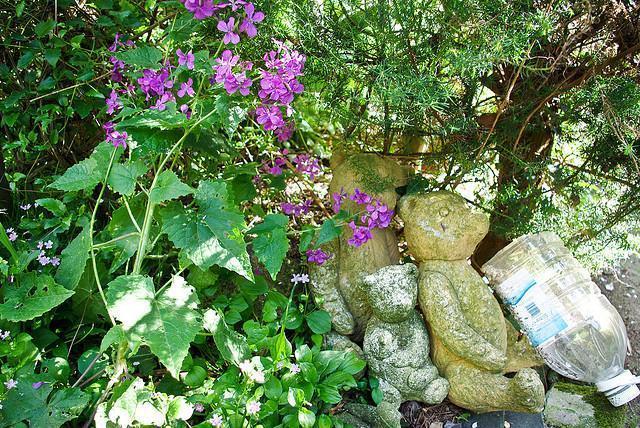How many teddy bears are in the picture?
Give a very brief answer. 3. 